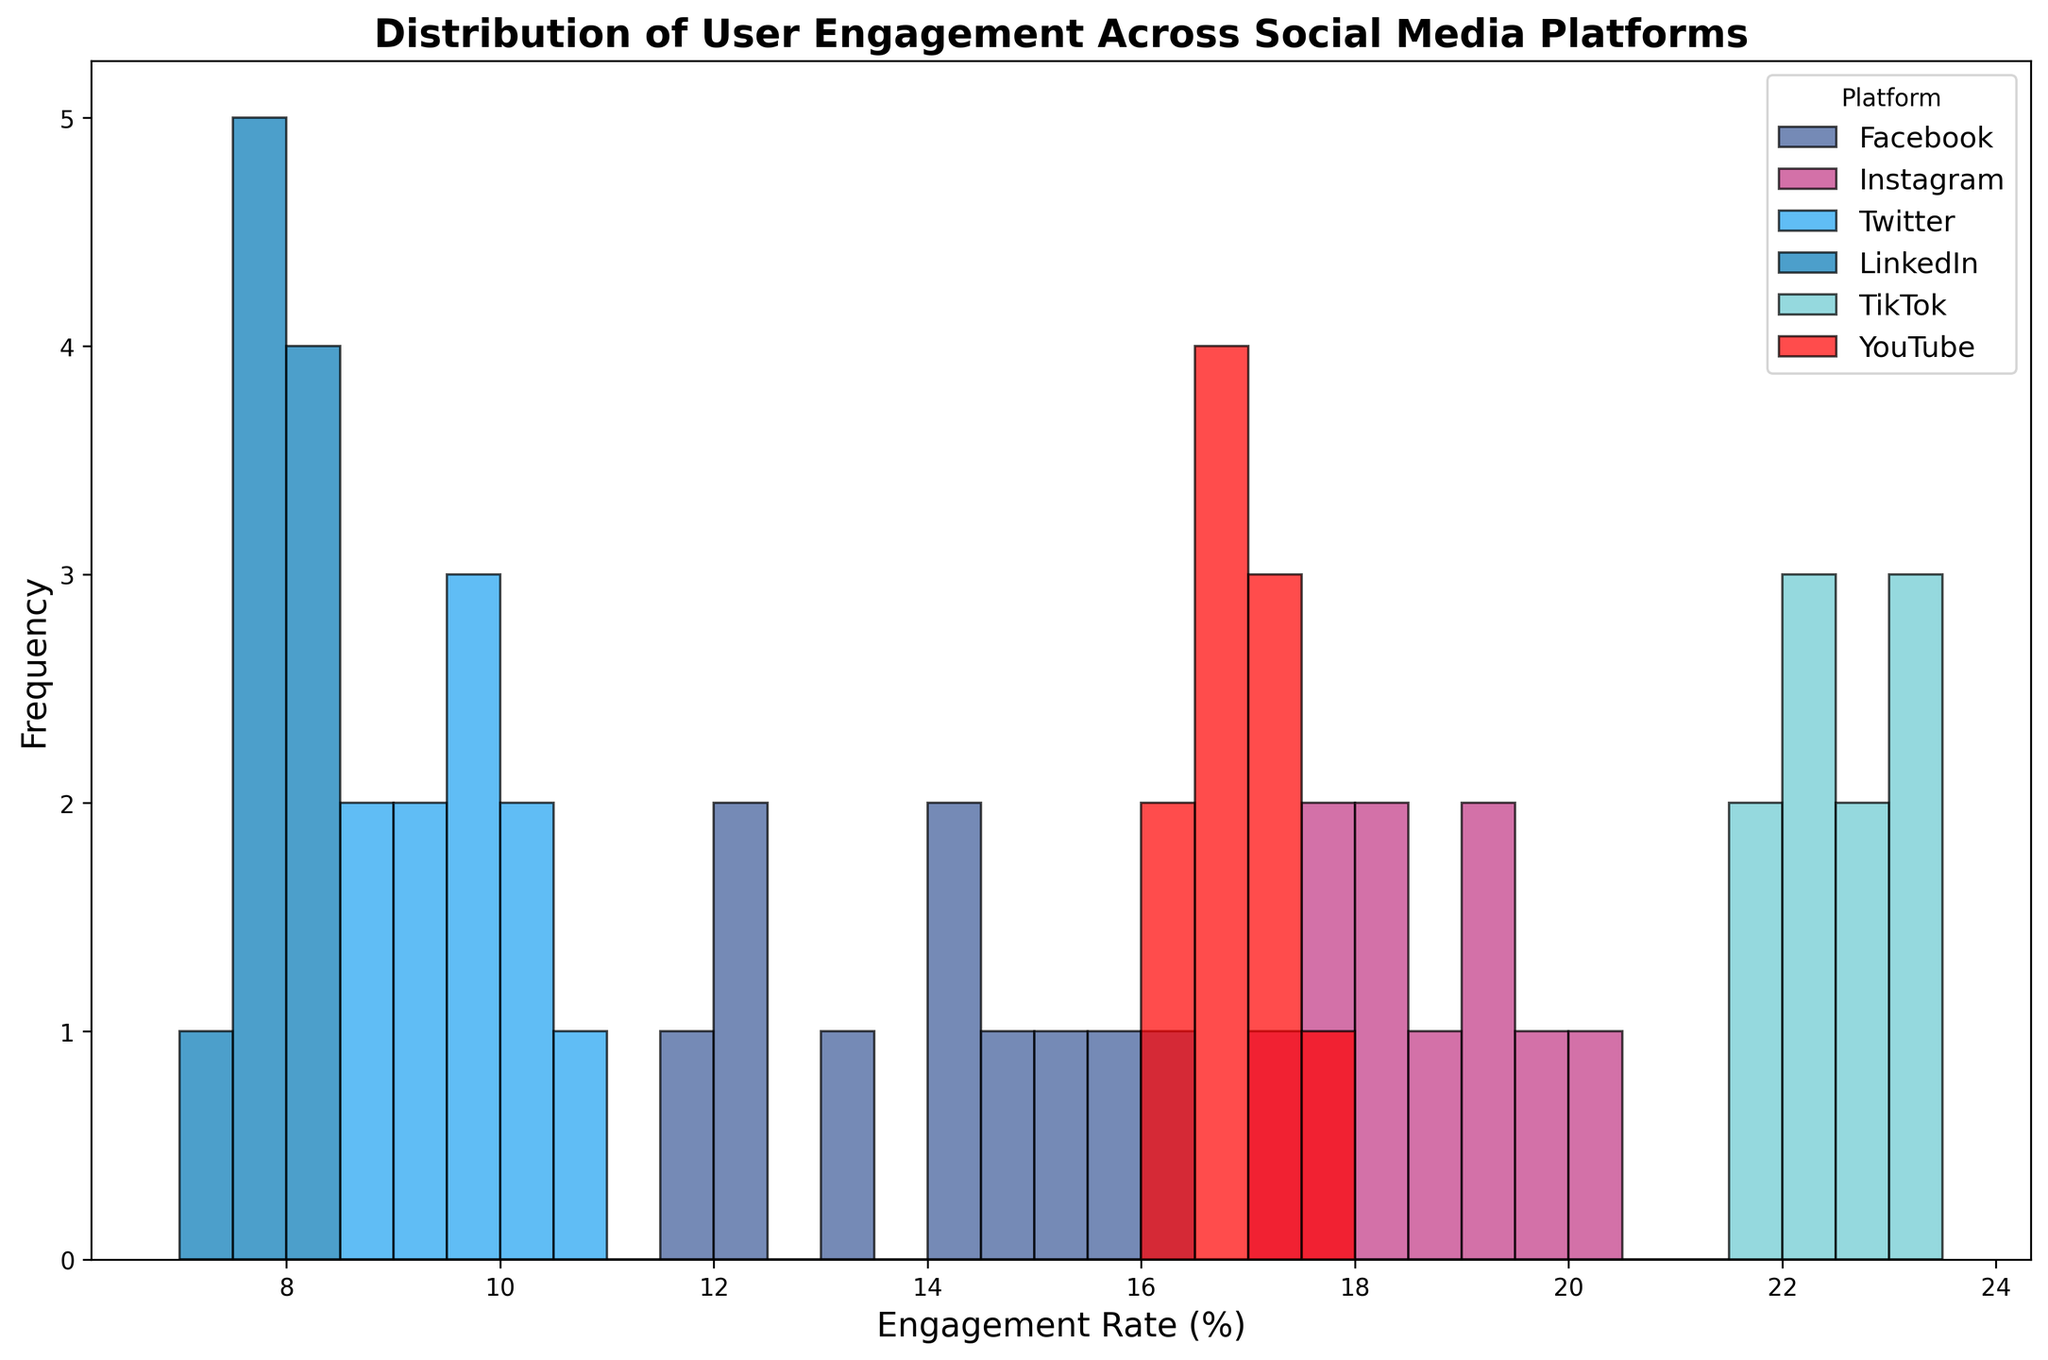Which social media platform has the widest range of user engagement rates? The width of the range can be determined by looking at the span of the engagement rates along the x-axis for each platform. TikTok spans from 21.5 to 23.2, which is the widest among all platforms.
Answer: TikTok Which platform has the highest peak in the histogram? The highest peak in the histogram represents the highest frequency of a particular engagement rate. TikTok, with rates around 22-23, has the tallest bar.
Answer: TikTok What is the average engagement rate for Facebook shown in the histogram? Calculate the sum of Facebook's engagement rates and divide by the number of data points. Sum: (12.4 + 15.6 + 14.3 + 11.9 + 13.2 + 16.1 + 12.0 + 14.0 + 15.0 + 14.7) = 139.2. Number of data points: 10. Average = 139.2 / 10 = 13.92.
Answer: 13.92 Which two platforms have engagement rates that overlap in the histogram, and what is the overlapping range? Instagram and YouTube are the closest in engagement rates, particularly overlapping between 17 and 18.
Answer: Instagram and YouTube; 17-18 How does the engagement rate distribution of Instagram compare to Twitter? Visually, Instagram's engagement rates are higher and more clustered around 17-20, whereas Twitter has lower engagement rates grouped between 8-10.
Answer: Instagram has higher rates What range of engagement rates is most frequent for LinkedIn? Observe the bars corresponding to LinkedIn, which peak in the 7.5-8.0 range.
Answer: 7.5-8.0 Which platform shows the least variance in user engagement? Variance can be visually estimated by the spread of the bars. LinkedIn has the narrowest spread among platforms.
Answer: LinkedIn Is there more variability in engagement rates for Facebook or YouTube? Facebook has a wider spread of engagement rates (ranging from about 11.9 to 16.1) compared to YouTube (16.1 to 17.5). Therefore, Facebook shows more variability.
Answer: Facebook What is the median engagement rate for YouTube? The median is the middle value when data points are ordered. Ordering YouTube's rates: (16.1, 16.3, 16.5, 16.7, 16.8, 16.9, 17.1, 17.2, 17.3, 17.5), the median is the average of the 5th and 6th values: (16.8 + 16.9) / 2 = 16.85.
Answer: 16.85 